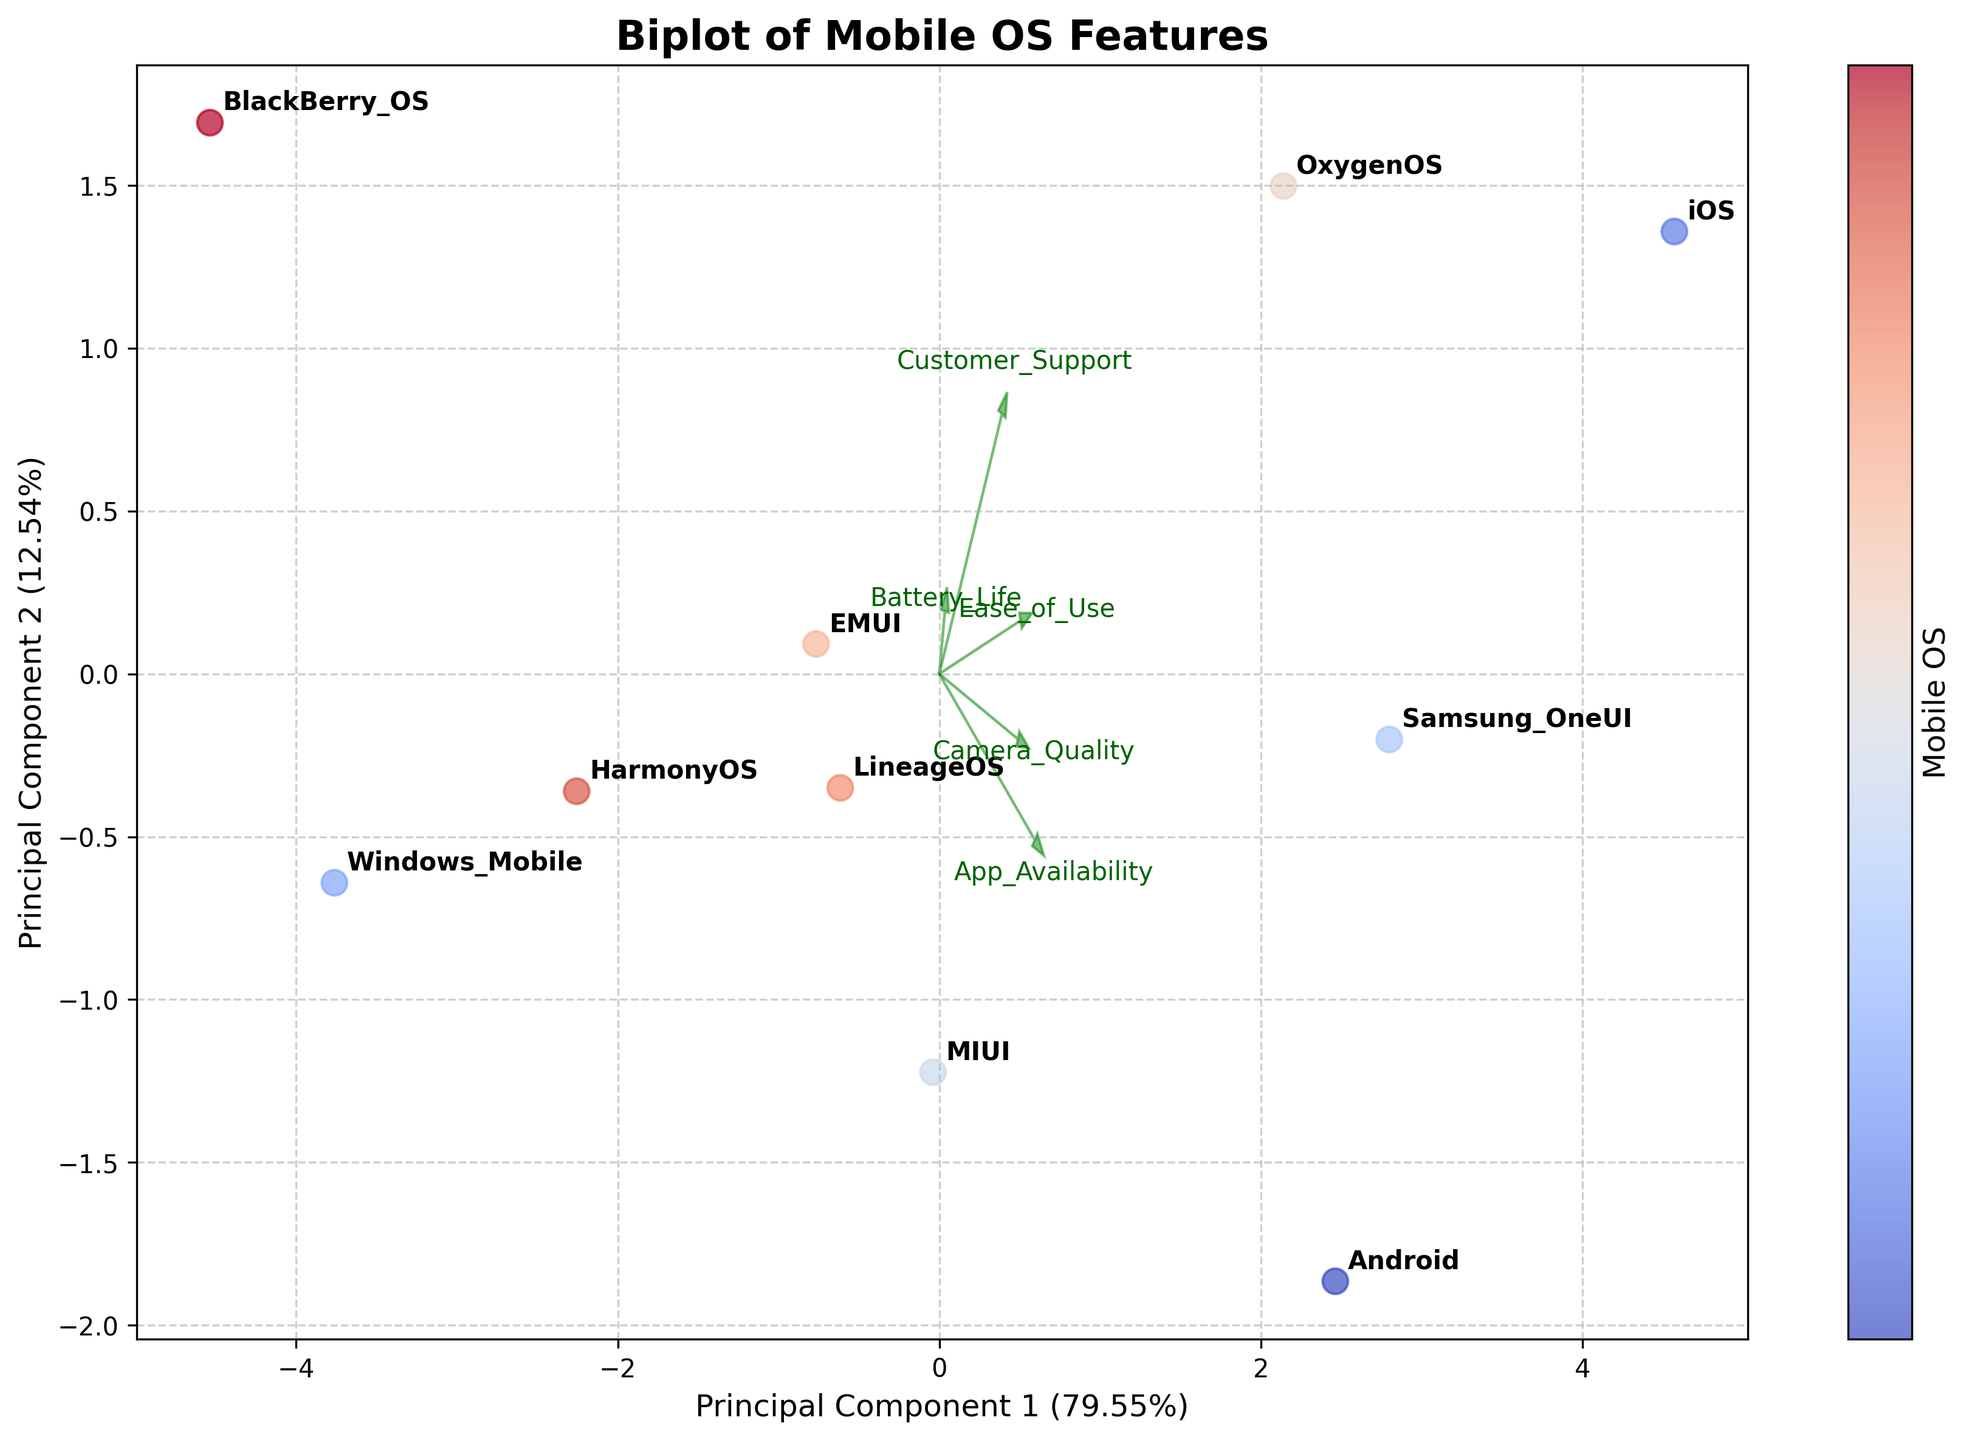What is the title of the biplot? The title of the plot is displayed at the top, which indicates the main subject of the plot
Answer: Biplot of Mobile OS Features How many mobile operating systems are displayed in the plot? Count the number of different OS labels annotated in the plot
Answer: 10 Which mobile operating system seems to be closer to the "Ease of Use" vector? Look for the OS that lies closest to the direction of the "Ease of Use" arrow
Answer: iOS Which feature vector appears to be the longest? Identify the feature vector with the largest magnitude, indicating it has the highest variance
Answer: Ease of Use Which two mobile operating systems are farthest apart on the plot? Identify the two OS labels that are furthest from each other in terms of plot space
Answer: iOS and BlackBerry_OS Which operating system exhibits similar vector positioning to Android? Locate the operating systems that have a nearby or similar position to Android on the plot
Answer: LineageOS What are the values of Principal Component 1 and Principal Component 2 expressed as percentages? Check the axis labels for Principal Component 1 and Principal Component 2 to see the explained variance ratios
Answer: Principal Component 1: 40%, Principal Component 2: 30% Which feature is most aligned with Principal Component 1? Determine the feature that has the largest contribution or alignment with the first principal component
Answer: Ease of Use Are there more mobile operating systems with positive or negative values on Principal Component 2? Count and compare the number of OS points that lie above and below the zero line on the Principal Component 2 axis
Answer: More with positive values Between "Battery Life" and "Camera Quality", which feature contributes more to Principal Component 2? Compare the position and contribution of the "Battery Life" and "Camera Quality" vectors in relation to Principal Component 2
Answer: Camera Quality 